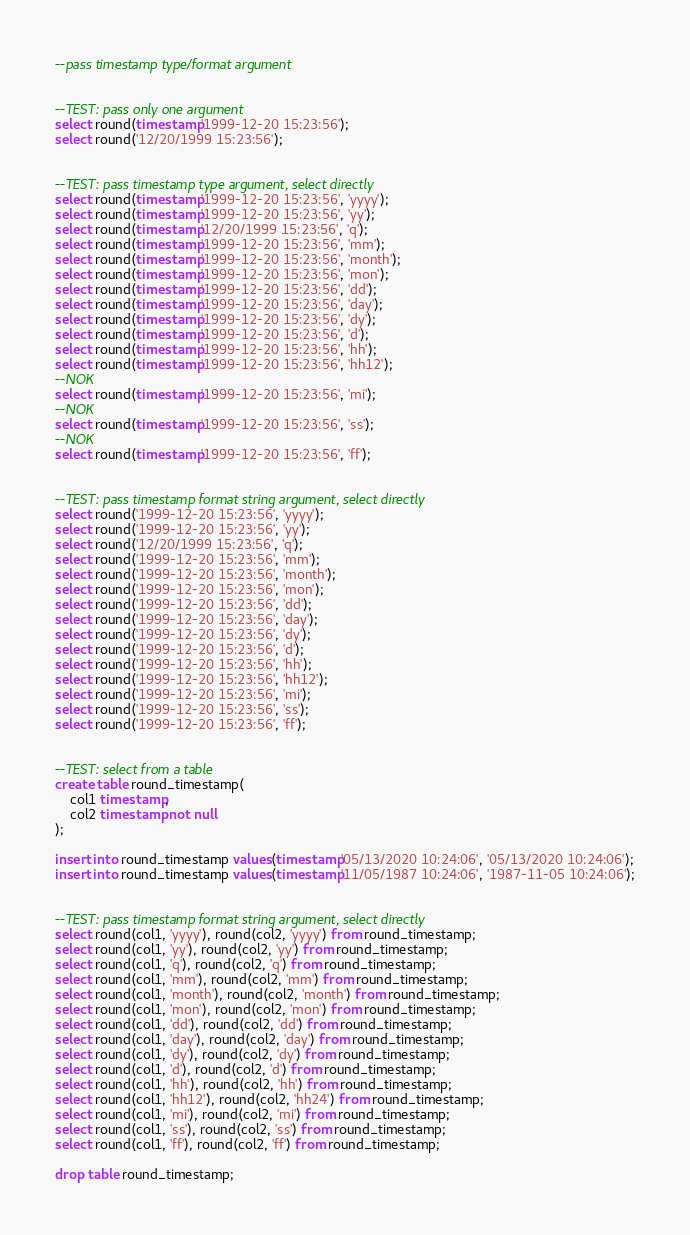Convert code to text. <code><loc_0><loc_0><loc_500><loc_500><_SQL_>--pass timestamp type/format argument


--TEST: pass only one argument
select round(timestamp'1999-12-20 15:23:56');
select round('12/20/1999 15:23:56');


--TEST: pass timestamp type argument, select directly
select round(timestamp'1999-12-20 15:23:56', 'yyyy');
select round(timestamp'1999-12-20 15:23:56', 'yy');
select round(timestamp'12/20/1999 15:23:56', 'q');
select round(timestamp'1999-12-20 15:23:56', 'mm');
select round(timestamp'1999-12-20 15:23:56', 'month');
select round(timestamp'1999-12-20 15:23:56', 'mon');
select round(timestamp'1999-12-20 15:23:56', 'dd');
select round(timestamp'1999-12-20 15:23:56', 'day');
select round(timestamp'1999-12-20 15:23:56', 'dy');
select round(timestamp'1999-12-20 15:23:56', 'd');
select round(timestamp'1999-12-20 15:23:56', 'hh');
select round(timestamp'1999-12-20 15:23:56', 'hh12');
--NOK
select round(timestamp'1999-12-20 15:23:56', 'mi');
--NOK
select round(timestamp'1999-12-20 15:23:56', 'ss');
--NOK
select round(timestamp'1999-12-20 15:23:56', 'ff');


--TEST: pass timestamp format string argument, select directly
select round('1999-12-20 15:23:56', 'yyyy');
select round('1999-12-20 15:23:56', 'yy');
select round('12/20/1999 15:23:56', 'q');
select round('1999-12-20 15:23:56', 'mm');
select round('1999-12-20 15:23:56', 'month');
select round('1999-12-20 15:23:56', 'mon');
select round('1999-12-20 15:23:56', 'dd');
select round('1999-12-20 15:23:56', 'day');
select round('1999-12-20 15:23:56', 'dy');
select round('1999-12-20 15:23:56', 'd');
select round('1999-12-20 15:23:56', 'hh');
select round('1999-12-20 15:23:56', 'hh12');
select round('1999-12-20 15:23:56', 'mi');
select round('1999-12-20 15:23:56', 'ss');
select round('1999-12-20 15:23:56', 'ff');


--TEST: select from a table
create table round_timestamp(
	col1 timestamp,
	col2 timestamp not null
);

insert into round_timestamp values(timestamp'05/13/2020 10:24:06', '05/13/2020 10:24:06');
insert into round_timestamp values(timestamp'11/05/1987 10:24:06', '1987-11-05 10:24:06');


--TEST: pass timestamp format string argument, select directly
select round(col1, 'yyyy'), round(col2, 'yyyy') from round_timestamp;
select round(col1, 'yy'), round(col2, 'yy') from round_timestamp;
select round(col1, 'q'), round(col2, 'q') from round_timestamp;
select round(col1, 'mm'), round(col2, 'mm') from round_timestamp;
select round(col1, 'month'), round(col2, 'month') from round_timestamp;
select round(col1, 'mon'), round(col2, 'mon') from round_timestamp;
select round(col1, 'dd'), round(col2, 'dd') from round_timestamp;
select round(col1, 'day'), round(col2, 'day') from round_timestamp;
select round(col1, 'dy'), round(col2, 'dy') from round_timestamp;
select round(col1, 'd'), round(col2, 'd') from round_timestamp;
select round(col1, 'hh'), round(col2, 'hh') from round_timestamp;
select round(col1, 'hh12'), round(col2, 'hh24') from round_timestamp;
select round(col1, 'mi'), round(col2, 'mi') from round_timestamp;
select round(col1, 'ss'), round(col2, 'ss') from round_timestamp;
select round(col1, 'ff'), round(col2, 'ff') from round_timestamp;

drop table round_timestamp;
</code> 